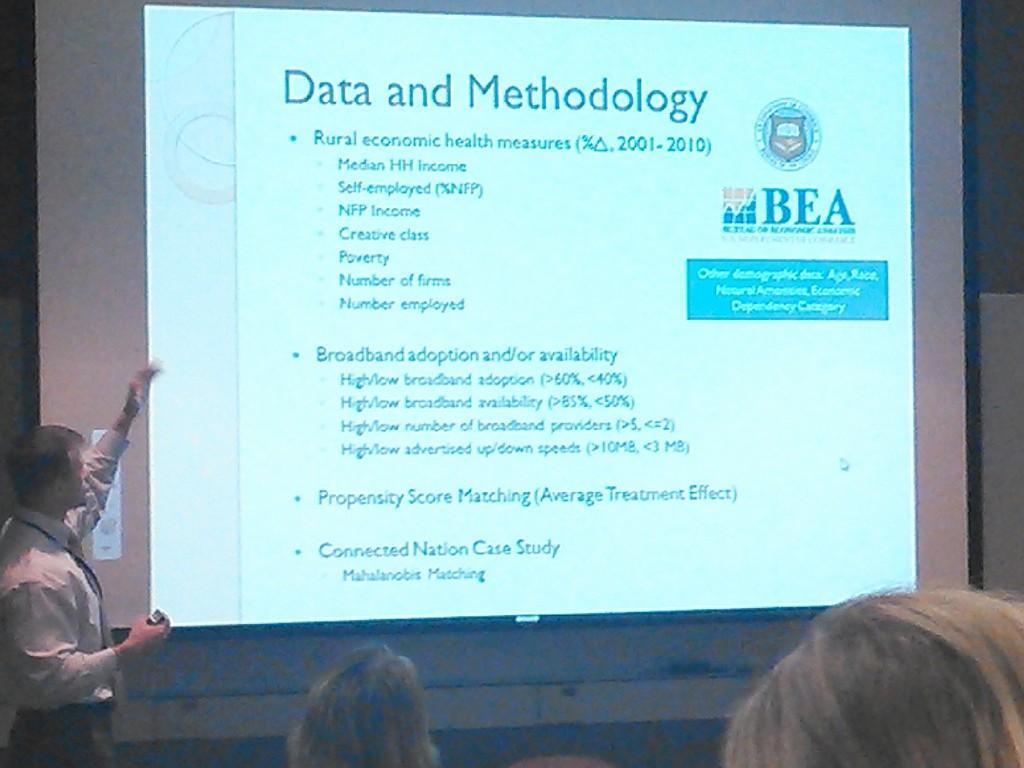How would you summarize this image in a sentence or two? In this image at front there are two persons. In front of them there is a screen. Behind the screen person is standing by holding the object. 